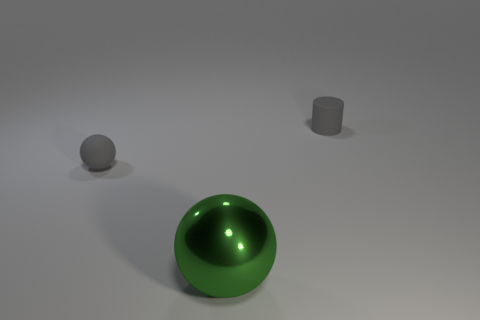What is the shape of the thing that is both behind the large thing and in front of the gray matte cylinder?
Your answer should be very brief. Sphere. There is a small object that is to the left of the green metal sphere; what number of balls are to the right of it?
Your answer should be compact. 1. Is the object behind the small matte ball made of the same material as the green thing?
Provide a succinct answer. No. Is there anything else that is the same material as the big green ball?
Make the answer very short. No. There is a rubber object that is behind the small gray rubber object left of the big thing; what size is it?
Give a very brief answer. Small. There is a matte object that is to the left of the tiny gray rubber cylinder behind the matte ball left of the tiny cylinder; what is its size?
Give a very brief answer. Small. There is a object on the right side of the big thing; does it have the same shape as the thing that is in front of the gray matte ball?
Keep it short and to the point. No. How many other things are there of the same color as the large sphere?
Your response must be concise. 0. There is a object on the right side of the green shiny sphere; is its size the same as the gray rubber sphere?
Ensure brevity in your answer.  Yes. Is the material of the object on the right side of the big shiny ball the same as the small gray object left of the green object?
Offer a very short reply. Yes. 